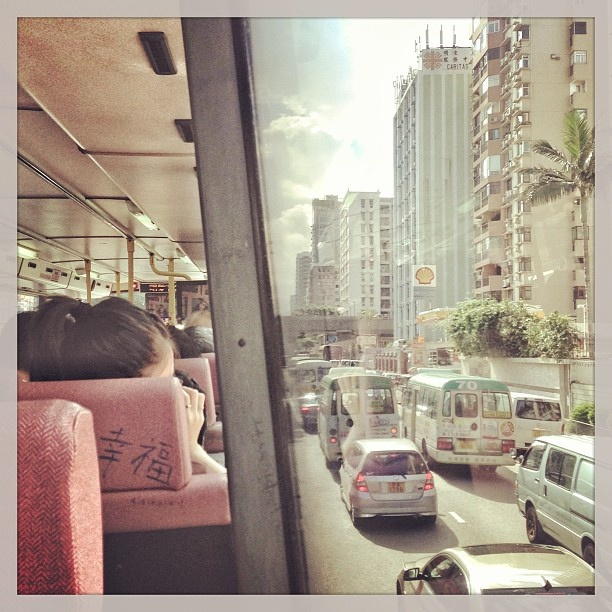Describe the objects in this image and their specific colors. I can see people in darkgray, gray, and black tones, bus in darkgray, beige, and gray tones, car in darkgray, ivory, beige, gray, and tan tones, car in darkgray, ivory, and gray tones, and car in darkgray, gray, and ivory tones in this image. 